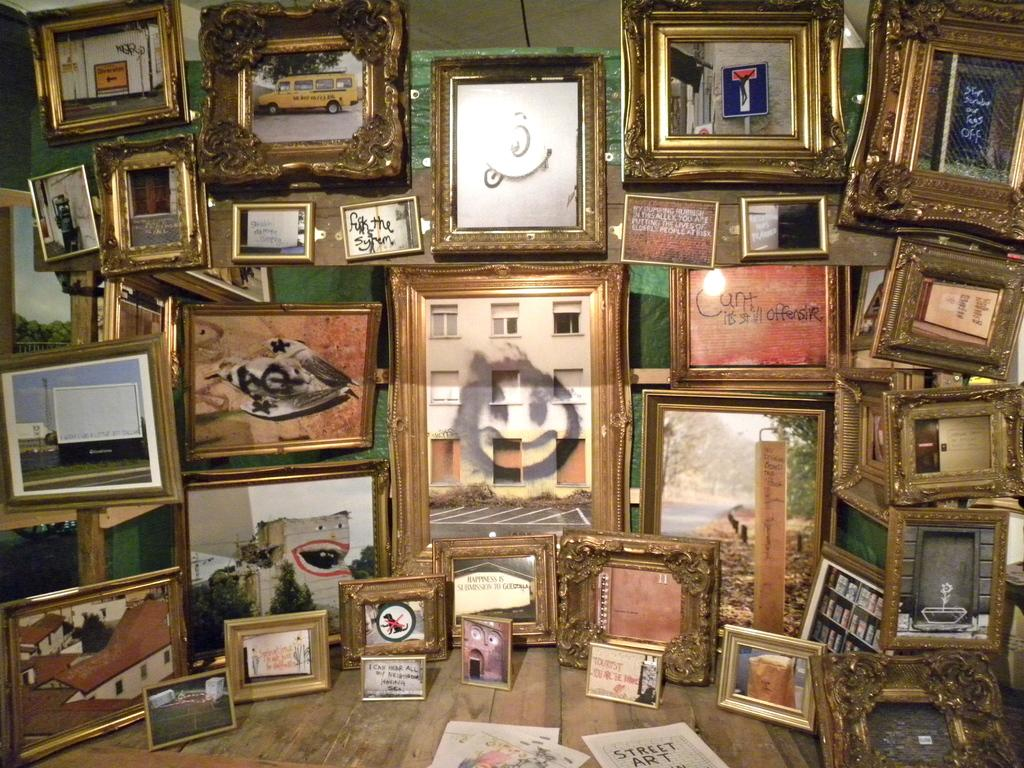What objects are present in the image that contain images? There are multiple photo frames in the image. What can be seen inside the photo frames? The photo frames contain different images. What type of support can be seen holding up the curtain in the image? There is no curtain or support present in the image, as a specific detail about the image that is known from the provided facts. 